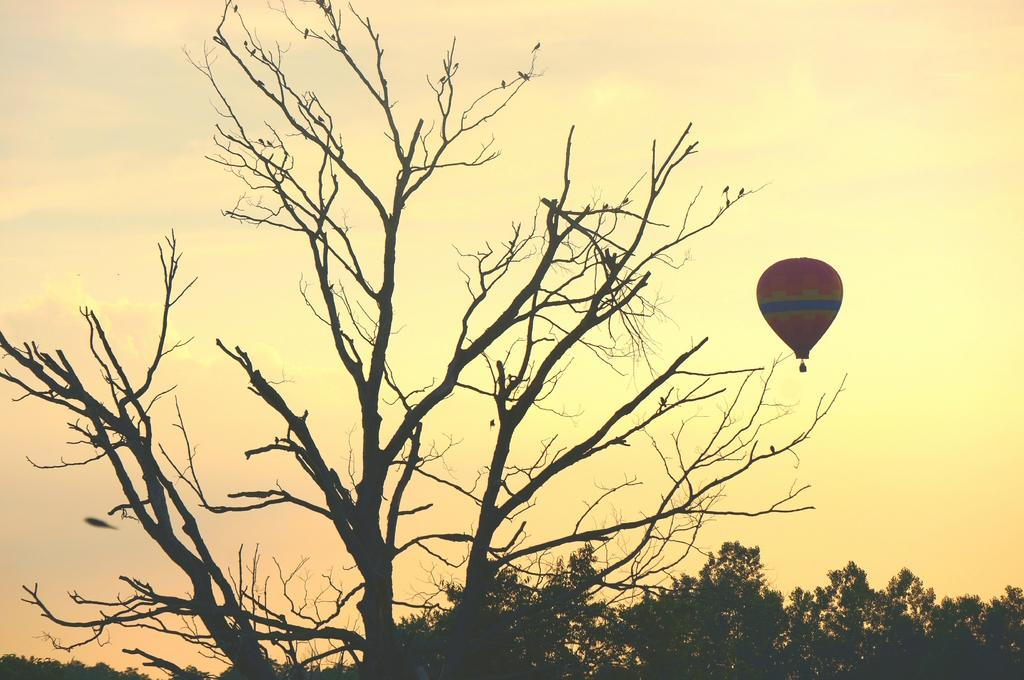What type of animals can be seen in the image? There are birds in the image. What type of vegetation is present in the image? There are trees in the image. What is located in the air in the image? There is a hot air balloon in the air. What can be seen in the background of the image? The sky is visible in the background of the image. What type of tent can be seen in the image? There is no tent present in the image. What emotion is being expressed by the man in the image? There is no man present in the image. 